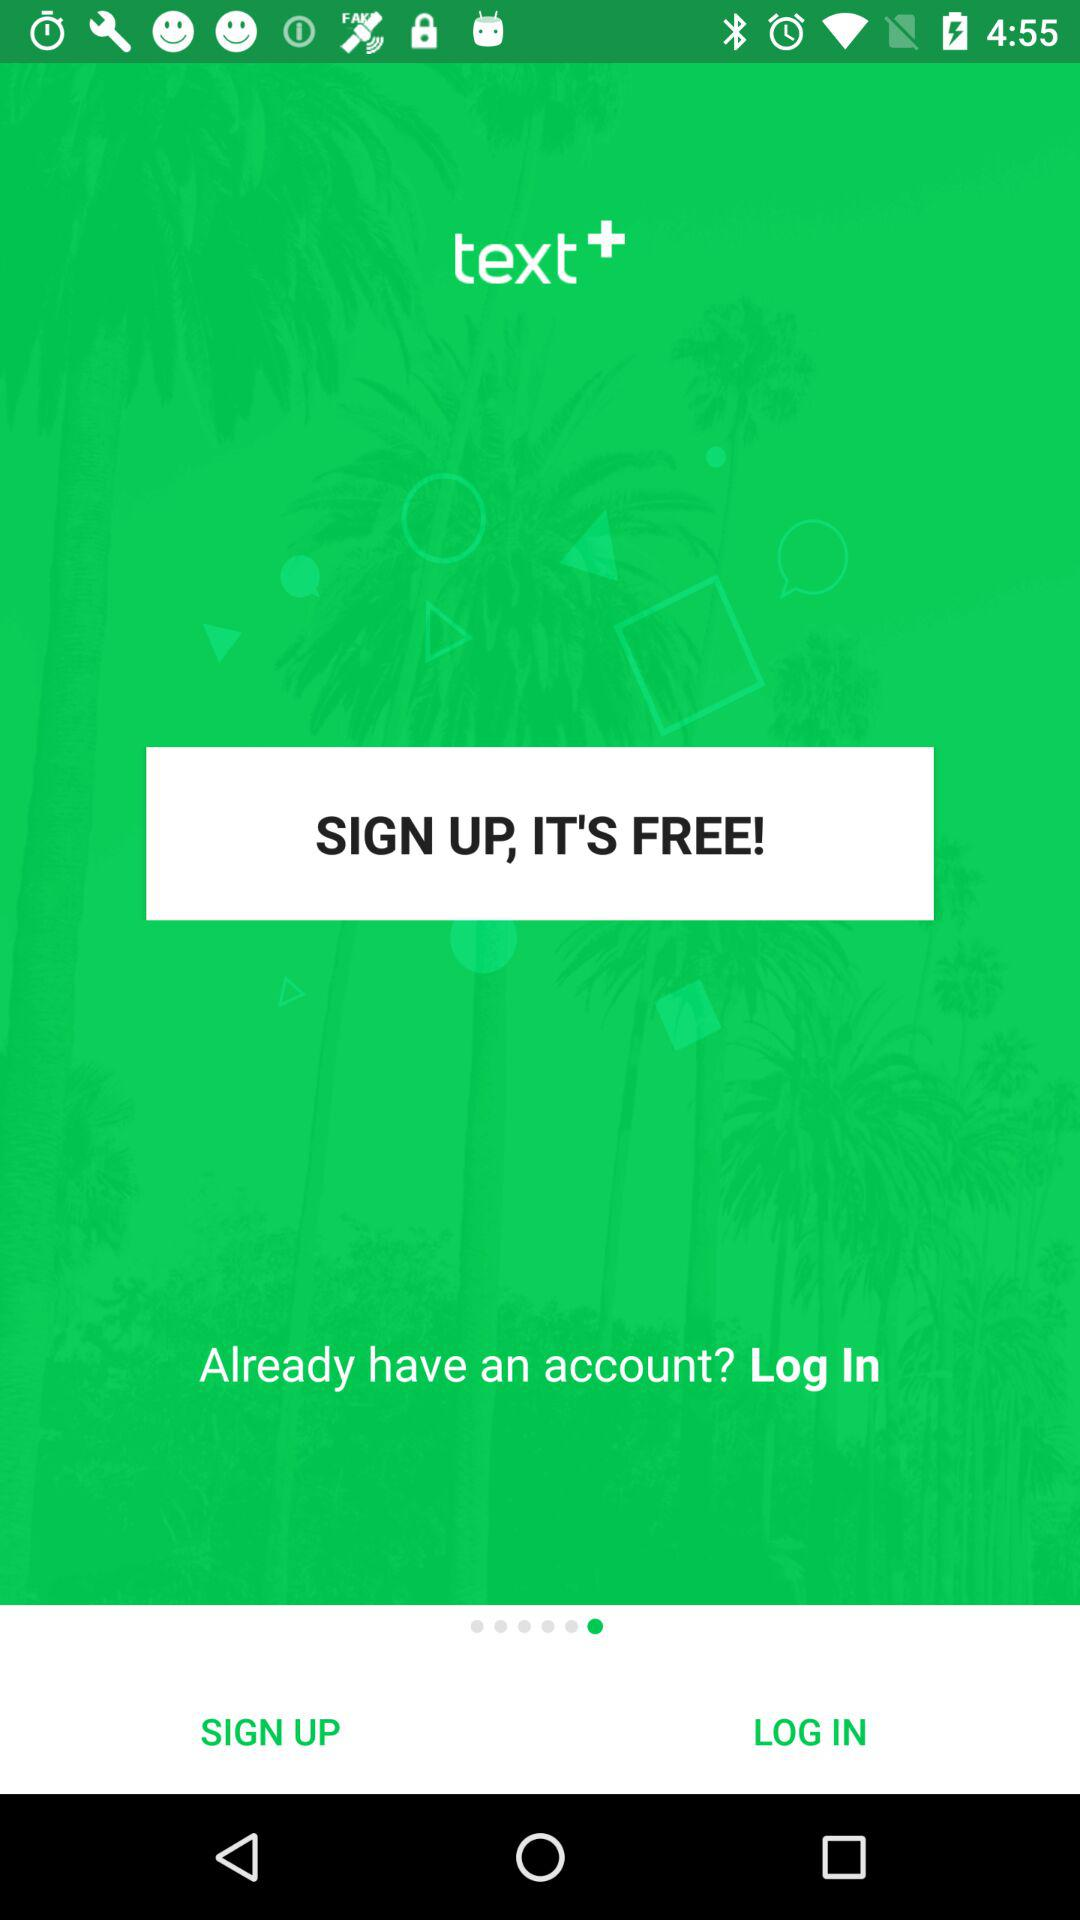What is the application name? The application name is "text+". 